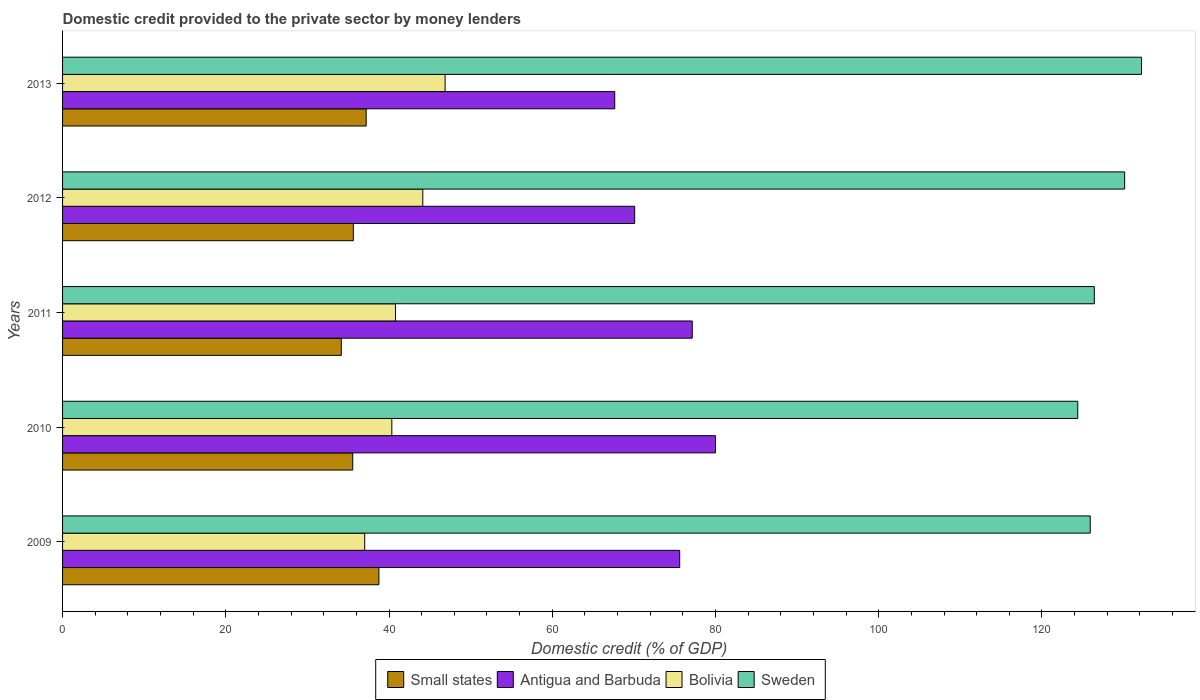How many different coloured bars are there?
Your answer should be very brief. 4. How many groups of bars are there?
Make the answer very short. 5. Are the number of bars on each tick of the Y-axis equal?
Ensure brevity in your answer.  Yes. How many bars are there on the 3rd tick from the bottom?
Your answer should be compact. 4. What is the label of the 5th group of bars from the top?
Keep it short and to the point. 2009. What is the domestic credit provided to the private sector by money lenders in Antigua and Barbuda in 2009?
Provide a short and direct response. 75.61. Across all years, what is the maximum domestic credit provided to the private sector by money lenders in Antigua and Barbuda?
Make the answer very short. 80. Across all years, what is the minimum domestic credit provided to the private sector by money lenders in Sweden?
Your answer should be very brief. 124.38. In which year was the domestic credit provided to the private sector by money lenders in Bolivia minimum?
Your response must be concise. 2009. What is the total domestic credit provided to the private sector by money lenders in Sweden in the graph?
Provide a succinct answer. 639.04. What is the difference between the domestic credit provided to the private sector by money lenders in Small states in 2011 and that in 2012?
Offer a terse response. -1.47. What is the difference between the domestic credit provided to the private sector by money lenders in Bolivia in 2011 and the domestic credit provided to the private sector by money lenders in Antigua and Barbuda in 2013?
Keep it short and to the point. -26.86. What is the average domestic credit provided to the private sector by money lenders in Antigua and Barbuda per year?
Offer a very short reply. 74.1. In the year 2012, what is the difference between the domestic credit provided to the private sector by money lenders in Bolivia and domestic credit provided to the private sector by money lenders in Sweden?
Provide a succinct answer. -85.99. What is the ratio of the domestic credit provided to the private sector by money lenders in Bolivia in 2009 to that in 2013?
Your response must be concise. 0.79. Is the difference between the domestic credit provided to the private sector by money lenders in Bolivia in 2010 and 2013 greater than the difference between the domestic credit provided to the private sector by money lenders in Sweden in 2010 and 2013?
Provide a short and direct response. Yes. What is the difference between the highest and the second highest domestic credit provided to the private sector by money lenders in Small states?
Offer a terse response. 1.56. What is the difference between the highest and the lowest domestic credit provided to the private sector by money lenders in Small states?
Your answer should be very brief. 4.61. Is the sum of the domestic credit provided to the private sector by money lenders in Bolivia in 2011 and 2013 greater than the maximum domestic credit provided to the private sector by money lenders in Sweden across all years?
Provide a succinct answer. No. Is it the case that in every year, the sum of the domestic credit provided to the private sector by money lenders in Antigua and Barbuda and domestic credit provided to the private sector by money lenders in Bolivia is greater than the sum of domestic credit provided to the private sector by money lenders in Small states and domestic credit provided to the private sector by money lenders in Sweden?
Your answer should be compact. No. What does the 1st bar from the bottom in 2013 represents?
Your answer should be compact. Small states. Is it the case that in every year, the sum of the domestic credit provided to the private sector by money lenders in Small states and domestic credit provided to the private sector by money lenders in Bolivia is greater than the domestic credit provided to the private sector by money lenders in Sweden?
Make the answer very short. No. How many years are there in the graph?
Offer a terse response. 5. What is the difference between two consecutive major ticks on the X-axis?
Provide a succinct answer. 20. Are the values on the major ticks of X-axis written in scientific E-notation?
Keep it short and to the point. No. How many legend labels are there?
Your answer should be compact. 4. How are the legend labels stacked?
Make the answer very short. Horizontal. What is the title of the graph?
Offer a very short reply. Domestic credit provided to the private sector by money lenders. Does "Curacao" appear as one of the legend labels in the graph?
Keep it short and to the point. No. What is the label or title of the X-axis?
Your response must be concise. Domestic credit (% of GDP). What is the label or title of the Y-axis?
Your answer should be very brief. Years. What is the Domestic credit (% of GDP) of Small states in 2009?
Offer a very short reply. 38.76. What is the Domestic credit (% of GDP) in Antigua and Barbuda in 2009?
Ensure brevity in your answer.  75.61. What is the Domestic credit (% of GDP) in Bolivia in 2009?
Provide a short and direct response. 37.02. What is the Domestic credit (% of GDP) in Sweden in 2009?
Give a very brief answer. 125.91. What is the Domestic credit (% of GDP) of Small states in 2010?
Your response must be concise. 35.55. What is the Domestic credit (% of GDP) of Antigua and Barbuda in 2010?
Your answer should be compact. 80. What is the Domestic credit (% of GDP) in Bolivia in 2010?
Provide a short and direct response. 40.34. What is the Domestic credit (% of GDP) in Sweden in 2010?
Ensure brevity in your answer.  124.38. What is the Domestic credit (% of GDP) in Small states in 2011?
Give a very brief answer. 34.15. What is the Domestic credit (% of GDP) in Antigua and Barbuda in 2011?
Provide a succinct answer. 77.15. What is the Domestic credit (% of GDP) of Bolivia in 2011?
Provide a succinct answer. 40.79. What is the Domestic credit (% of GDP) in Sweden in 2011?
Give a very brief answer. 126.41. What is the Domestic credit (% of GDP) of Small states in 2012?
Offer a very short reply. 35.63. What is the Domestic credit (% of GDP) in Antigua and Barbuda in 2012?
Provide a short and direct response. 70.1. What is the Domestic credit (% of GDP) of Bolivia in 2012?
Ensure brevity in your answer.  44.14. What is the Domestic credit (% of GDP) of Sweden in 2012?
Your response must be concise. 130.13. What is the Domestic credit (% of GDP) in Small states in 2013?
Your response must be concise. 37.2. What is the Domestic credit (% of GDP) of Antigua and Barbuda in 2013?
Offer a terse response. 67.65. What is the Domestic credit (% of GDP) of Bolivia in 2013?
Your response must be concise. 46.87. What is the Domestic credit (% of GDP) of Sweden in 2013?
Your answer should be very brief. 132.2. Across all years, what is the maximum Domestic credit (% of GDP) of Small states?
Your answer should be compact. 38.76. Across all years, what is the maximum Domestic credit (% of GDP) in Antigua and Barbuda?
Give a very brief answer. 80. Across all years, what is the maximum Domestic credit (% of GDP) in Bolivia?
Offer a terse response. 46.87. Across all years, what is the maximum Domestic credit (% of GDP) of Sweden?
Your answer should be very brief. 132.2. Across all years, what is the minimum Domestic credit (% of GDP) of Small states?
Offer a very short reply. 34.15. Across all years, what is the minimum Domestic credit (% of GDP) in Antigua and Barbuda?
Ensure brevity in your answer.  67.65. Across all years, what is the minimum Domestic credit (% of GDP) in Bolivia?
Provide a succinct answer. 37.02. Across all years, what is the minimum Domestic credit (% of GDP) of Sweden?
Make the answer very short. 124.38. What is the total Domestic credit (% of GDP) in Small states in the graph?
Your answer should be very brief. 181.29. What is the total Domestic credit (% of GDP) of Antigua and Barbuda in the graph?
Provide a short and direct response. 370.52. What is the total Domestic credit (% of GDP) of Bolivia in the graph?
Offer a very short reply. 209.16. What is the total Domestic credit (% of GDP) in Sweden in the graph?
Provide a short and direct response. 639.04. What is the difference between the Domestic credit (% of GDP) of Small states in 2009 and that in 2010?
Give a very brief answer. 3.21. What is the difference between the Domestic credit (% of GDP) of Antigua and Barbuda in 2009 and that in 2010?
Your response must be concise. -4.38. What is the difference between the Domestic credit (% of GDP) in Bolivia in 2009 and that in 2010?
Offer a very short reply. -3.32. What is the difference between the Domestic credit (% of GDP) in Sweden in 2009 and that in 2010?
Your answer should be very brief. 1.53. What is the difference between the Domestic credit (% of GDP) of Small states in 2009 and that in 2011?
Provide a short and direct response. 4.61. What is the difference between the Domestic credit (% of GDP) of Antigua and Barbuda in 2009 and that in 2011?
Make the answer very short. -1.54. What is the difference between the Domestic credit (% of GDP) in Bolivia in 2009 and that in 2011?
Offer a very short reply. -3.77. What is the difference between the Domestic credit (% of GDP) in Sweden in 2009 and that in 2011?
Provide a succinct answer. -0.5. What is the difference between the Domestic credit (% of GDP) in Small states in 2009 and that in 2012?
Your answer should be compact. 3.13. What is the difference between the Domestic credit (% of GDP) in Antigua and Barbuda in 2009 and that in 2012?
Keep it short and to the point. 5.52. What is the difference between the Domestic credit (% of GDP) in Bolivia in 2009 and that in 2012?
Ensure brevity in your answer.  -7.12. What is the difference between the Domestic credit (% of GDP) of Sweden in 2009 and that in 2012?
Your response must be concise. -4.22. What is the difference between the Domestic credit (% of GDP) of Small states in 2009 and that in 2013?
Keep it short and to the point. 1.56. What is the difference between the Domestic credit (% of GDP) in Antigua and Barbuda in 2009 and that in 2013?
Offer a very short reply. 7.96. What is the difference between the Domestic credit (% of GDP) of Bolivia in 2009 and that in 2013?
Offer a terse response. -9.85. What is the difference between the Domestic credit (% of GDP) of Sweden in 2009 and that in 2013?
Provide a short and direct response. -6.29. What is the difference between the Domestic credit (% of GDP) of Small states in 2010 and that in 2011?
Offer a terse response. 1.4. What is the difference between the Domestic credit (% of GDP) of Antigua and Barbuda in 2010 and that in 2011?
Ensure brevity in your answer.  2.85. What is the difference between the Domestic credit (% of GDP) of Bolivia in 2010 and that in 2011?
Offer a very short reply. -0.45. What is the difference between the Domestic credit (% of GDP) in Sweden in 2010 and that in 2011?
Your response must be concise. -2.03. What is the difference between the Domestic credit (% of GDP) of Small states in 2010 and that in 2012?
Offer a terse response. -0.07. What is the difference between the Domestic credit (% of GDP) in Antigua and Barbuda in 2010 and that in 2012?
Ensure brevity in your answer.  9.9. What is the difference between the Domestic credit (% of GDP) of Bolivia in 2010 and that in 2012?
Provide a succinct answer. -3.79. What is the difference between the Domestic credit (% of GDP) in Sweden in 2010 and that in 2012?
Provide a short and direct response. -5.74. What is the difference between the Domestic credit (% of GDP) of Small states in 2010 and that in 2013?
Ensure brevity in your answer.  -1.64. What is the difference between the Domestic credit (% of GDP) in Antigua and Barbuda in 2010 and that in 2013?
Offer a very short reply. 12.35. What is the difference between the Domestic credit (% of GDP) of Bolivia in 2010 and that in 2013?
Make the answer very short. -6.53. What is the difference between the Domestic credit (% of GDP) in Sweden in 2010 and that in 2013?
Keep it short and to the point. -7.82. What is the difference between the Domestic credit (% of GDP) of Small states in 2011 and that in 2012?
Your answer should be compact. -1.47. What is the difference between the Domestic credit (% of GDP) in Antigua and Barbuda in 2011 and that in 2012?
Keep it short and to the point. 7.05. What is the difference between the Domestic credit (% of GDP) in Bolivia in 2011 and that in 2012?
Your answer should be very brief. -3.34. What is the difference between the Domestic credit (% of GDP) of Sweden in 2011 and that in 2012?
Provide a succinct answer. -3.71. What is the difference between the Domestic credit (% of GDP) of Small states in 2011 and that in 2013?
Offer a very short reply. -3.04. What is the difference between the Domestic credit (% of GDP) of Antigua and Barbuda in 2011 and that in 2013?
Ensure brevity in your answer.  9.5. What is the difference between the Domestic credit (% of GDP) in Bolivia in 2011 and that in 2013?
Your answer should be compact. -6.08. What is the difference between the Domestic credit (% of GDP) of Sweden in 2011 and that in 2013?
Your answer should be very brief. -5.79. What is the difference between the Domestic credit (% of GDP) in Small states in 2012 and that in 2013?
Keep it short and to the point. -1.57. What is the difference between the Domestic credit (% of GDP) of Antigua and Barbuda in 2012 and that in 2013?
Your answer should be compact. 2.44. What is the difference between the Domestic credit (% of GDP) of Bolivia in 2012 and that in 2013?
Make the answer very short. -2.73. What is the difference between the Domestic credit (% of GDP) of Sweden in 2012 and that in 2013?
Ensure brevity in your answer.  -2.07. What is the difference between the Domestic credit (% of GDP) in Small states in 2009 and the Domestic credit (% of GDP) in Antigua and Barbuda in 2010?
Keep it short and to the point. -41.24. What is the difference between the Domestic credit (% of GDP) in Small states in 2009 and the Domestic credit (% of GDP) in Bolivia in 2010?
Keep it short and to the point. -1.58. What is the difference between the Domestic credit (% of GDP) of Small states in 2009 and the Domestic credit (% of GDP) of Sweden in 2010?
Offer a very short reply. -85.62. What is the difference between the Domestic credit (% of GDP) in Antigua and Barbuda in 2009 and the Domestic credit (% of GDP) in Bolivia in 2010?
Your response must be concise. 35.27. What is the difference between the Domestic credit (% of GDP) of Antigua and Barbuda in 2009 and the Domestic credit (% of GDP) of Sweden in 2010?
Your answer should be very brief. -48.77. What is the difference between the Domestic credit (% of GDP) of Bolivia in 2009 and the Domestic credit (% of GDP) of Sweden in 2010?
Your answer should be very brief. -87.37. What is the difference between the Domestic credit (% of GDP) in Small states in 2009 and the Domestic credit (% of GDP) in Antigua and Barbuda in 2011?
Ensure brevity in your answer.  -38.39. What is the difference between the Domestic credit (% of GDP) of Small states in 2009 and the Domestic credit (% of GDP) of Bolivia in 2011?
Keep it short and to the point. -2.03. What is the difference between the Domestic credit (% of GDP) in Small states in 2009 and the Domestic credit (% of GDP) in Sweden in 2011?
Your answer should be compact. -87.65. What is the difference between the Domestic credit (% of GDP) in Antigua and Barbuda in 2009 and the Domestic credit (% of GDP) in Bolivia in 2011?
Your answer should be very brief. 34.82. What is the difference between the Domestic credit (% of GDP) in Antigua and Barbuda in 2009 and the Domestic credit (% of GDP) in Sweden in 2011?
Ensure brevity in your answer.  -50.8. What is the difference between the Domestic credit (% of GDP) of Bolivia in 2009 and the Domestic credit (% of GDP) of Sweden in 2011?
Ensure brevity in your answer.  -89.4. What is the difference between the Domestic credit (% of GDP) in Small states in 2009 and the Domestic credit (% of GDP) in Antigua and Barbuda in 2012?
Make the answer very short. -31.34. What is the difference between the Domestic credit (% of GDP) of Small states in 2009 and the Domestic credit (% of GDP) of Bolivia in 2012?
Your answer should be compact. -5.38. What is the difference between the Domestic credit (% of GDP) in Small states in 2009 and the Domestic credit (% of GDP) in Sweden in 2012?
Keep it short and to the point. -91.37. What is the difference between the Domestic credit (% of GDP) of Antigua and Barbuda in 2009 and the Domestic credit (% of GDP) of Bolivia in 2012?
Offer a terse response. 31.48. What is the difference between the Domestic credit (% of GDP) in Antigua and Barbuda in 2009 and the Domestic credit (% of GDP) in Sweden in 2012?
Ensure brevity in your answer.  -54.51. What is the difference between the Domestic credit (% of GDP) of Bolivia in 2009 and the Domestic credit (% of GDP) of Sweden in 2012?
Offer a very short reply. -93.11. What is the difference between the Domestic credit (% of GDP) in Small states in 2009 and the Domestic credit (% of GDP) in Antigua and Barbuda in 2013?
Give a very brief answer. -28.89. What is the difference between the Domestic credit (% of GDP) of Small states in 2009 and the Domestic credit (% of GDP) of Bolivia in 2013?
Your answer should be compact. -8.11. What is the difference between the Domestic credit (% of GDP) of Small states in 2009 and the Domestic credit (% of GDP) of Sweden in 2013?
Your response must be concise. -93.44. What is the difference between the Domestic credit (% of GDP) of Antigua and Barbuda in 2009 and the Domestic credit (% of GDP) of Bolivia in 2013?
Provide a short and direct response. 28.74. What is the difference between the Domestic credit (% of GDP) in Antigua and Barbuda in 2009 and the Domestic credit (% of GDP) in Sweden in 2013?
Offer a very short reply. -56.59. What is the difference between the Domestic credit (% of GDP) of Bolivia in 2009 and the Domestic credit (% of GDP) of Sweden in 2013?
Provide a succinct answer. -95.18. What is the difference between the Domestic credit (% of GDP) of Small states in 2010 and the Domestic credit (% of GDP) of Antigua and Barbuda in 2011?
Keep it short and to the point. -41.6. What is the difference between the Domestic credit (% of GDP) in Small states in 2010 and the Domestic credit (% of GDP) in Bolivia in 2011?
Give a very brief answer. -5.24. What is the difference between the Domestic credit (% of GDP) in Small states in 2010 and the Domestic credit (% of GDP) in Sweden in 2011?
Keep it short and to the point. -90.86. What is the difference between the Domestic credit (% of GDP) in Antigua and Barbuda in 2010 and the Domestic credit (% of GDP) in Bolivia in 2011?
Make the answer very short. 39.21. What is the difference between the Domestic credit (% of GDP) in Antigua and Barbuda in 2010 and the Domestic credit (% of GDP) in Sweden in 2011?
Offer a very short reply. -46.41. What is the difference between the Domestic credit (% of GDP) of Bolivia in 2010 and the Domestic credit (% of GDP) of Sweden in 2011?
Ensure brevity in your answer.  -86.07. What is the difference between the Domestic credit (% of GDP) in Small states in 2010 and the Domestic credit (% of GDP) in Antigua and Barbuda in 2012?
Your answer should be compact. -34.54. What is the difference between the Domestic credit (% of GDP) in Small states in 2010 and the Domestic credit (% of GDP) in Bolivia in 2012?
Offer a terse response. -8.58. What is the difference between the Domestic credit (% of GDP) in Small states in 2010 and the Domestic credit (% of GDP) in Sweden in 2012?
Your response must be concise. -94.58. What is the difference between the Domestic credit (% of GDP) of Antigua and Barbuda in 2010 and the Domestic credit (% of GDP) of Bolivia in 2012?
Ensure brevity in your answer.  35.86. What is the difference between the Domestic credit (% of GDP) in Antigua and Barbuda in 2010 and the Domestic credit (% of GDP) in Sweden in 2012?
Your answer should be very brief. -50.13. What is the difference between the Domestic credit (% of GDP) in Bolivia in 2010 and the Domestic credit (% of GDP) in Sweden in 2012?
Make the answer very short. -89.79. What is the difference between the Domestic credit (% of GDP) in Small states in 2010 and the Domestic credit (% of GDP) in Antigua and Barbuda in 2013?
Ensure brevity in your answer.  -32.1. What is the difference between the Domestic credit (% of GDP) of Small states in 2010 and the Domestic credit (% of GDP) of Bolivia in 2013?
Keep it short and to the point. -11.32. What is the difference between the Domestic credit (% of GDP) in Small states in 2010 and the Domestic credit (% of GDP) in Sweden in 2013?
Make the answer very short. -96.65. What is the difference between the Domestic credit (% of GDP) in Antigua and Barbuda in 2010 and the Domestic credit (% of GDP) in Bolivia in 2013?
Ensure brevity in your answer.  33.13. What is the difference between the Domestic credit (% of GDP) in Antigua and Barbuda in 2010 and the Domestic credit (% of GDP) in Sweden in 2013?
Offer a terse response. -52.2. What is the difference between the Domestic credit (% of GDP) in Bolivia in 2010 and the Domestic credit (% of GDP) in Sweden in 2013?
Give a very brief answer. -91.86. What is the difference between the Domestic credit (% of GDP) in Small states in 2011 and the Domestic credit (% of GDP) in Antigua and Barbuda in 2012?
Provide a succinct answer. -35.94. What is the difference between the Domestic credit (% of GDP) of Small states in 2011 and the Domestic credit (% of GDP) of Bolivia in 2012?
Offer a terse response. -9.98. What is the difference between the Domestic credit (% of GDP) in Small states in 2011 and the Domestic credit (% of GDP) in Sweden in 2012?
Your answer should be compact. -95.97. What is the difference between the Domestic credit (% of GDP) of Antigua and Barbuda in 2011 and the Domestic credit (% of GDP) of Bolivia in 2012?
Your answer should be compact. 33.01. What is the difference between the Domestic credit (% of GDP) of Antigua and Barbuda in 2011 and the Domestic credit (% of GDP) of Sweden in 2012?
Your response must be concise. -52.98. What is the difference between the Domestic credit (% of GDP) of Bolivia in 2011 and the Domestic credit (% of GDP) of Sweden in 2012?
Make the answer very short. -89.34. What is the difference between the Domestic credit (% of GDP) of Small states in 2011 and the Domestic credit (% of GDP) of Antigua and Barbuda in 2013?
Your response must be concise. -33.5. What is the difference between the Domestic credit (% of GDP) of Small states in 2011 and the Domestic credit (% of GDP) of Bolivia in 2013?
Keep it short and to the point. -12.72. What is the difference between the Domestic credit (% of GDP) of Small states in 2011 and the Domestic credit (% of GDP) of Sweden in 2013?
Offer a terse response. -98.05. What is the difference between the Domestic credit (% of GDP) of Antigua and Barbuda in 2011 and the Domestic credit (% of GDP) of Bolivia in 2013?
Offer a very short reply. 30.28. What is the difference between the Domestic credit (% of GDP) of Antigua and Barbuda in 2011 and the Domestic credit (% of GDP) of Sweden in 2013?
Your answer should be compact. -55.05. What is the difference between the Domestic credit (% of GDP) of Bolivia in 2011 and the Domestic credit (% of GDP) of Sweden in 2013?
Keep it short and to the point. -91.41. What is the difference between the Domestic credit (% of GDP) in Small states in 2012 and the Domestic credit (% of GDP) in Antigua and Barbuda in 2013?
Keep it short and to the point. -32.03. What is the difference between the Domestic credit (% of GDP) in Small states in 2012 and the Domestic credit (% of GDP) in Bolivia in 2013?
Ensure brevity in your answer.  -11.24. What is the difference between the Domestic credit (% of GDP) in Small states in 2012 and the Domestic credit (% of GDP) in Sweden in 2013?
Offer a terse response. -96.57. What is the difference between the Domestic credit (% of GDP) of Antigua and Barbuda in 2012 and the Domestic credit (% of GDP) of Bolivia in 2013?
Ensure brevity in your answer.  23.23. What is the difference between the Domestic credit (% of GDP) of Antigua and Barbuda in 2012 and the Domestic credit (% of GDP) of Sweden in 2013?
Your response must be concise. -62.1. What is the difference between the Domestic credit (% of GDP) of Bolivia in 2012 and the Domestic credit (% of GDP) of Sweden in 2013?
Give a very brief answer. -88.06. What is the average Domestic credit (% of GDP) of Small states per year?
Give a very brief answer. 36.26. What is the average Domestic credit (% of GDP) of Antigua and Barbuda per year?
Ensure brevity in your answer.  74.1. What is the average Domestic credit (% of GDP) in Bolivia per year?
Your answer should be compact. 41.83. What is the average Domestic credit (% of GDP) of Sweden per year?
Give a very brief answer. 127.81. In the year 2009, what is the difference between the Domestic credit (% of GDP) of Small states and Domestic credit (% of GDP) of Antigua and Barbuda?
Your answer should be very brief. -36.85. In the year 2009, what is the difference between the Domestic credit (% of GDP) of Small states and Domestic credit (% of GDP) of Bolivia?
Give a very brief answer. 1.74. In the year 2009, what is the difference between the Domestic credit (% of GDP) in Small states and Domestic credit (% of GDP) in Sweden?
Offer a very short reply. -87.15. In the year 2009, what is the difference between the Domestic credit (% of GDP) of Antigua and Barbuda and Domestic credit (% of GDP) of Bolivia?
Your answer should be very brief. 38.6. In the year 2009, what is the difference between the Domestic credit (% of GDP) in Antigua and Barbuda and Domestic credit (% of GDP) in Sweden?
Give a very brief answer. -50.3. In the year 2009, what is the difference between the Domestic credit (% of GDP) in Bolivia and Domestic credit (% of GDP) in Sweden?
Make the answer very short. -88.89. In the year 2010, what is the difference between the Domestic credit (% of GDP) of Small states and Domestic credit (% of GDP) of Antigua and Barbuda?
Your answer should be compact. -44.45. In the year 2010, what is the difference between the Domestic credit (% of GDP) in Small states and Domestic credit (% of GDP) in Bolivia?
Ensure brevity in your answer.  -4.79. In the year 2010, what is the difference between the Domestic credit (% of GDP) in Small states and Domestic credit (% of GDP) in Sweden?
Make the answer very short. -88.83. In the year 2010, what is the difference between the Domestic credit (% of GDP) in Antigua and Barbuda and Domestic credit (% of GDP) in Bolivia?
Give a very brief answer. 39.66. In the year 2010, what is the difference between the Domestic credit (% of GDP) in Antigua and Barbuda and Domestic credit (% of GDP) in Sweden?
Make the answer very short. -44.39. In the year 2010, what is the difference between the Domestic credit (% of GDP) of Bolivia and Domestic credit (% of GDP) of Sweden?
Provide a succinct answer. -84.04. In the year 2011, what is the difference between the Domestic credit (% of GDP) of Small states and Domestic credit (% of GDP) of Antigua and Barbuda?
Offer a very short reply. -43. In the year 2011, what is the difference between the Domestic credit (% of GDP) in Small states and Domestic credit (% of GDP) in Bolivia?
Provide a succinct answer. -6.64. In the year 2011, what is the difference between the Domestic credit (% of GDP) of Small states and Domestic credit (% of GDP) of Sweden?
Make the answer very short. -92.26. In the year 2011, what is the difference between the Domestic credit (% of GDP) in Antigua and Barbuda and Domestic credit (% of GDP) in Bolivia?
Offer a terse response. 36.36. In the year 2011, what is the difference between the Domestic credit (% of GDP) in Antigua and Barbuda and Domestic credit (% of GDP) in Sweden?
Offer a terse response. -49.26. In the year 2011, what is the difference between the Domestic credit (% of GDP) in Bolivia and Domestic credit (% of GDP) in Sweden?
Make the answer very short. -85.62. In the year 2012, what is the difference between the Domestic credit (% of GDP) in Small states and Domestic credit (% of GDP) in Antigua and Barbuda?
Keep it short and to the point. -34.47. In the year 2012, what is the difference between the Domestic credit (% of GDP) in Small states and Domestic credit (% of GDP) in Bolivia?
Offer a terse response. -8.51. In the year 2012, what is the difference between the Domestic credit (% of GDP) of Small states and Domestic credit (% of GDP) of Sweden?
Provide a succinct answer. -94.5. In the year 2012, what is the difference between the Domestic credit (% of GDP) in Antigua and Barbuda and Domestic credit (% of GDP) in Bolivia?
Offer a very short reply. 25.96. In the year 2012, what is the difference between the Domestic credit (% of GDP) of Antigua and Barbuda and Domestic credit (% of GDP) of Sweden?
Make the answer very short. -60.03. In the year 2012, what is the difference between the Domestic credit (% of GDP) of Bolivia and Domestic credit (% of GDP) of Sweden?
Provide a short and direct response. -85.99. In the year 2013, what is the difference between the Domestic credit (% of GDP) in Small states and Domestic credit (% of GDP) in Antigua and Barbuda?
Give a very brief answer. -30.46. In the year 2013, what is the difference between the Domestic credit (% of GDP) of Small states and Domestic credit (% of GDP) of Bolivia?
Your response must be concise. -9.67. In the year 2013, what is the difference between the Domestic credit (% of GDP) in Small states and Domestic credit (% of GDP) in Sweden?
Your response must be concise. -95. In the year 2013, what is the difference between the Domestic credit (% of GDP) of Antigua and Barbuda and Domestic credit (% of GDP) of Bolivia?
Provide a short and direct response. 20.78. In the year 2013, what is the difference between the Domestic credit (% of GDP) of Antigua and Barbuda and Domestic credit (% of GDP) of Sweden?
Give a very brief answer. -64.55. In the year 2013, what is the difference between the Domestic credit (% of GDP) in Bolivia and Domestic credit (% of GDP) in Sweden?
Your answer should be very brief. -85.33. What is the ratio of the Domestic credit (% of GDP) in Small states in 2009 to that in 2010?
Ensure brevity in your answer.  1.09. What is the ratio of the Domestic credit (% of GDP) in Antigua and Barbuda in 2009 to that in 2010?
Offer a very short reply. 0.95. What is the ratio of the Domestic credit (% of GDP) of Bolivia in 2009 to that in 2010?
Give a very brief answer. 0.92. What is the ratio of the Domestic credit (% of GDP) in Sweden in 2009 to that in 2010?
Provide a short and direct response. 1.01. What is the ratio of the Domestic credit (% of GDP) in Small states in 2009 to that in 2011?
Ensure brevity in your answer.  1.13. What is the ratio of the Domestic credit (% of GDP) in Antigua and Barbuda in 2009 to that in 2011?
Your response must be concise. 0.98. What is the ratio of the Domestic credit (% of GDP) in Bolivia in 2009 to that in 2011?
Your answer should be compact. 0.91. What is the ratio of the Domestic credit (% of GDP) of Sweden in 2009 to that in 2011?
Your answer should be compact. 1. What is the ratio of the Domestic credit (% of GDP) in Small states in 2009 to that in 2012?
Your answer should be compact. 1.09. What is the ratio of the Domestic credit (% of GDP) in Antigua and Barbuda in 2009 to that in 2012?
Make the answer very short. 1.08. What is the ratio of the Domestic credit (% of GDP) of Bolivia in 2009 to that in 2012?
Give a very brief answer. 0.84. What is the ratio of the Domestic credit (% of GDP) of Sweden in 2009 to that in 2012?
Give a very brief answer. 0.97. What is the ratio of the Domestic credit (% of GDP) of Small states in 2009 to that in 2013?
Ensure brevity in your answer.  1.04. What is the ratio of the Domestic credit (% of GDP) of Antigua and Barbuda in 2009 to that in 2013?
Your answer should be compact. 1.12. What is the ratio of the Domestic credit (% of GDP) of Bolivia in 2009 to that in 2013?
Keep it short and to the point. 0.79. What is the ratio of the Domestic credit (% of GDP) in Sweden in 2009 to that in 2013?
Your answer should be very brief. 0.95. What is the ratio of the Domestic credit (% of GDP) in Small states in 2010 to that in 2011?
Offer a very short reply. 1.04. What is the ratio of the Domestic credit (% of GDP) of Antigua and Barbuda in 2010 to that in 2011?
Your answer should be compact. 1.04. What is the ratio of the Domestic credit (% of GDP) in Bolivia in 2010 to that in 2011?
Provide a succinct answer. 0.99. What is the ratio of the Domestic credit (% of GDP) of Sweden in 2010 to that in 2011?
Keep it short and to the point. 0.98. What is the ratio of the Domestic credit (% of GDP) of Antigua and Barbuda in 2010 to that in 2012?
Keep it short and to the point. 1.14. What is the ratio of the Domestic credit (% of GDP) of Bolivia in 2010 to that in 2012?
Your answer should be very brief. 0.91. What is the ratio of the Domestic credit (% of GDP) in Sweden in 2010 to that in 2012?
Provide a succinct answer. 0.96. What is the ratio of the Domestic credit (% of GDP) of Small states in 2010 to that in 2013?
Your answer should be compact. 0.96. What is the ratio of the Domestic credit (% of GDP) of Antigua and Barbuda in 2010 to that in 2013?
Make the answer very short. 1.18. What is the ratio of the Domestic credit (% of GDP) of Bolivia in 2010 to that in 2013?
Keep it short and to the point. 0.86. What is the ratio of the Domestic credit (% of GDP) in Sweden in 2010 to that in 2013?
Give a very brief answer. 0.94. What is the ratio of the Domestic credit (% of GDP) of Small states in 2011 to that in 2012?
Offer a terse response. 0.96. What is the ratio of the Domestic credit (% of GDP) in Antigua and Barbuda in 2011 to that in 2012?
Make the answer very short. 1.1. What is the ratio of the Domestic credit (% of GDP) in Bolivia in 2011 to that in 2012?
Offer a terse response. 0.92. What is the ratio of the Domestic credit (% of GDP) of Sweden in 2011 to that in 2012?
Your response must be concise. 0.97. What is the ratio of the Domestic credit (% of GDP) in Small states in 2011 to that in 2013?
Your response must be concise. 0.92. What is the ratio of the Domestic credit (% of GDP) in Antigua and Barbuda in 2011 to that in 2013?
Your response must be concise. 1.14. What is the ratio of the Domestic credit (% of GDP) in Bolivia in 2011 to that in 2013?
Keep it short and to the point. 0.87. What is the ratio of the Domestic credit (% of GDP) of Sweden in 2011 to that in 2013?
Your answer should be very brief. 0.96. What is the ratio of the Domestic credit (% of GDP) of Small states in 2012 to that in 2013?
Offer a very short reply. 0.96. What is the ratio of the Domestic credit (% of GDP) of Antigua and Barbuda in 2012 to that in 2013?
Provide a short and direct response. 1.04. What is the ratio of the Domestic credit (% of GDP) in Bolivia in 2012 to that in 2013?
Provide a succinct answer. 0.94. What is the ratio of the Domestic credit (% of GDP) of Sweden in 2012 to that in 2013?
Your answer should be very brief. 0.98. What is the difference between the highest and the second highest Domestic credit (% of GDP) of Small states?
Your answer should be compact. 1.56. What is the difference between the highest and the second highest Domestic credit (% of GDP) in Antigua and Barbuda?
Offer a terse response. 2.85. What is the difference between the highest and the second highest Domestic credit (% of GDP) of Bolivia?
Make the answer very short. 2.73. What is the difference between the highest and the second highest Domestic credit (% of GDP) of Sweden?
Offer a terse response. 2.07. What is the difference between the highest and the lowest Domestic credit (% of GDP) in Small states?
Your answer should be very brief. 4.61. What is the difference between the highest and the lowest Domestic credit (% of GDP) in Antigua and Barbuda?
Provide a short and direct response. 12.35. What is the difference between the highest and the lowest Domestic credit (% of GDP) in Bolivia?
Provide a short and direct response. 9.85. What is the difference between the highest and the lowest Domestic credit (% of GDP) in Sweden?
Your response must be concise. 7.82. 